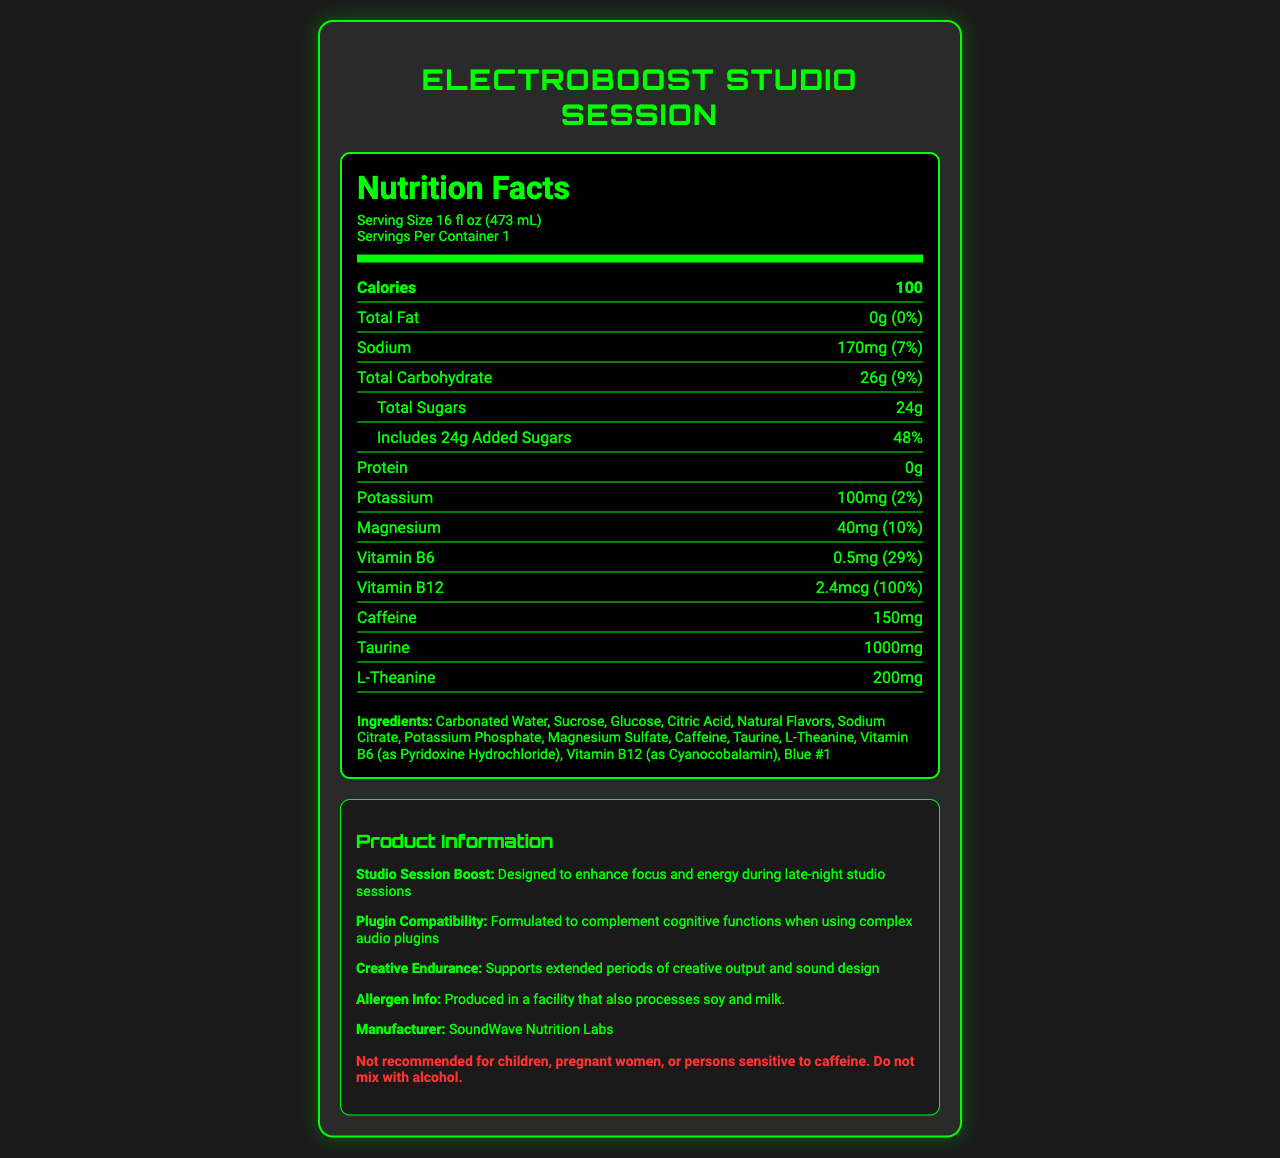what is the serving size of ElectroBoost Studio Session? The serving size is clearly mentioned as 16 fl oz (473 mL) at the top of the nutrition facts section.
Answer: 16 fl oz (473 mL) how many calories are in a serving of this drink? The calories per serving are stated as 100 in bold within the nutrition facts.
Answer: 100 how much sodium does this drink contain? The sodium content is listed as 170mg in the nutrition facts.
Answer: 170mg what percentage of the daily value for added sugars does this drink provide? The daily value percentage for added sugars is given as 48% underneath the total sugars section.
Answer: 48% what is the amount of caffeine present in the drink? The amount of caffeine is indicated as 150mg in the nutrition facts.
Answer: 150mg how much potassium does the ElectroBoost Studio Session contain? A. 100mg B. 150mg C. 170mg The amount of potassium is given as 100mg in the nutrition facts.
Answer: A. 100mg which of the following ingredients is not present in ElectroBoost Studio Session? i. Sucrose ii. Stevia iii. Blue #1 Stevia is not listed among the ingredients, which include Sucrose and Blue #1.
Answer: ii. Stevia is ElectroBoost Studio Session safe for children and pregnant women? The warning section explicitly states that the drink is not recommended for children or pregnant women.
Answer: No describe the main nutritional benefits of ElectroBoost Studio Session. The document outlines that the drink aims to boost focus and energy specifically for late-night studio sessions. It provides key nutrients and stimulants like caffeine, taurine, L-theanine, and various vitamins and minerals to support cognitive functions and creative endurance.
Answer: ElectroBoost Studio Session is designed to enhance focus and energy during late-night studio sessions, providing 100 calories, 170mg sodium, 26g carbohydrates (with 24g sugars), 150mg caffeine, 1000mg taurine, and 200mg L-theanine. It also supports creative endurance and plugin compatibility while featuring essential vitamins and minerals such as magnesium, vitamin B6, and vitamin B12. what is the manufacturer of ElectroBoost Studio Session? The manufacturer is listed at the end of the product information section as SoundWave Nutrition Labs.
Answer: SoundWave Nutrition Labs what percentage of daily value of vitamin B12 is provided by ElectroBoost Studio Session? The percentage of daily value for vitamin B12 is clearly stated as 100%.
Answer: 100% what is the total carbohydrate content, and what is its daily value percentage? The total carbohydrate content is 26g, and its daily value percentage is 9%.
Answer: 26g, 9% can ElectroBoost Studio Session be consumed by individuals sensitive to caffeine? The warning section clearly mentions that the drink is not recommended for persons sensitive to caffeine.
Answer: No how many servings are there per container? The document states that there is 1 serving per container right under the serving size information.
Answer: 1 what is the total amount of protein in this drink? The amount of protein is given as 0g in the nutrition facts.
Answer: 0g how much magnesium is in ElectroBoost Studio Session? A. 10mg B. 20mg C. 40mg The amount of magnesium is listed as 40mg in the nutrition facts section.
Answer: C. 40mg based on the nutritional information provided, can you determine if this drink contains calcium? The document does not provide any information regarding calcium content, so it cannot be determined from the given data.
Answer: Not enough information 